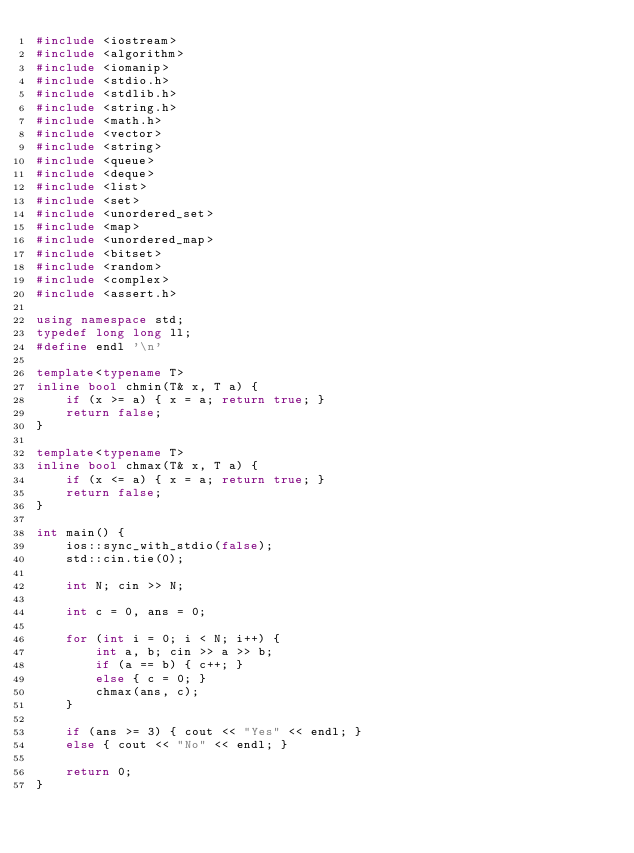Convert code to text. <code><loc_0><loc_0><loc_500><loc_500><_C++_>#include <iostream>
#include <algorithm>
#include <iomanip>
#include <stdio.h>
#include <stdlib.h>
#include <string.h>
#include <math.h>
#include <vector>
#include <string>
#include <queue>
#include <deque>
#include <list>
#include <set>
#include <unordered_set>
#include <map>
#include <unordered_map>
#include <bitset>
#include <random>
#include <complex>
#include <assert.h>

using namespace std;
typedef long long ll;
#define endl '\n'

template<typename T>
inline bool chmin(T& x, T a) {
	if (x >= a) { x = a; return true; }
	return false;
}

template<typename T>
inline bool chmax(T& x, T a) {
	if (x <= a) { x = a; return true; }
	return false;
}

int main() {
	ios::sync_with_stdio(false);
	std::cin.tie(0);

	int N; cin >> N;

	int c = 0, ans = 0;

	for (int i = 0; i < N; i++) {
		int a, b; cin >> a >> b;
		if (a == b) { c++; }
		else { c = 0; }
		chmax(ans, c);
	}

	if (ans >= 3) { cout << "Yes" << endl; }
	else { cout << "No" << endl; }

	return 0;
}</code> 